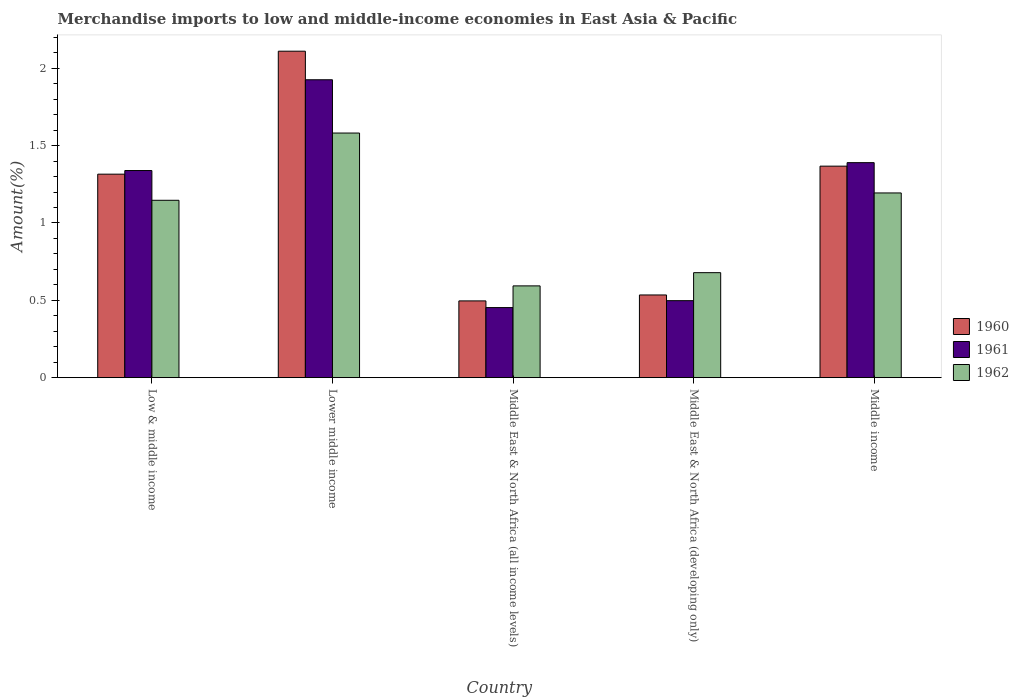How many different coloured bars are there?
Offer a terse response. 3. How many groups of bars are there?
Offer a terse response. 5. Are the number of bars per tick equal to the number of legend labels?
Provide a succinct answer. Yes. How many bars are there on the 4th tick from the left?
Give a very brief answer. 3. What is the percentage of amount earned from merchandise imports in 1961 in Middle East & North Africa (developing only)?
Give a very brief answer. 0.5. Across all countries, what is the maximum percentage of amount earned from merchandise imports in 1960?
Ensure brevity in your answer.  2.11. Across all countries, what is the minimum percentage of amount earned from merchandise imports in 1960?
Offer a very short reply. 0.5. In which country was the percentage of amount earned from merchandise imports in 1961 maximum?
Offer a very short reply. Lower middle income. In which country was the percentage of amount earned from merchandise imports in 1961 minimum?
Make the answer very short. Middle East & North Africa (all income levels). What is the total percentage of amount earned from merchandise imports in 1961 in the graph?
Your answer should be very brief. 5.61. What is the difference between the percentage of amount earned from merchandise imports in 1962 in Low & middle income and that in Middle East & North Africa (developing only)?
Provide a short and direct response. 0.47. What is the difference between the percentage of amount earned from merchandise imports in 1961 in Low & middle income and the percentage of amount earned from merchandise imports in 1962 in Middle East & North Africa (developing only)?
Your response must be concise. 0.66. What is the average percentage of amount earned from merchandise imports in 1960 per country?
Provide a succinct answer. 1.16. What is the difference between the percentage of amount earned from merchandise imports of/in 1961 and percentage of amount earned from merchandise imports of/in 1960 in Lower middle income?
Offer a terse response. -0.18. What is the ratio of the percentage of amount earned from merchandise imports in 1962 in Lower middle income to that in Middle East & North Africa (developing only)?
Your response must be concise. 2.33. Is the percentage of amount earned from merchandise imports in 1961 in Middle East & North Africa (developing only) less than that in Middle income?
Your response must be concise. Yes. Is the difference between the percentage of amount earned from merchandise imports in 1961 in Lower middle income and Middle East & North Africa (developing only) greater than the difference between the percentage of amount earned from merchandise imports in 1960 in Lower middle income and Middle East & North Africa (developing only)?
Provide a succinct answer. No. What is the difference between the highest and the second highest percentage of amount earned from merchandise imports in 1962?
Provide a short and direct response. 0.43. What is the difference between the highest and the lowest percentage of amount earned from merchandise imports in 1961?
Provide a short and direct response. 1.47. Is the sum of the percentage of amount earned from merchandise imports in 1961 in Middle East & North Africa (developing only) and Middle income greater than the maximum percentage of amount earned from merchandise imports in 1962 across all countries?
Ensure brevity in your answer.  Yes. What does the 3rd bar from the right in Middle East & North Africa (all income levels) represents?
Offer a very short reply. 1960. Is it the case that in every country, the sum of the percentage of amount earned from merchandise imports in 1960 and percentage of amount earned from merchandise imports in 1962 is greater than the percentage of amount earned from merchandise imports in 1961?
Provide a short and direct response. Yes. How many bars are there?
Offer a very short reply. 15. Are all the bars in the graph horizontal?
Offer a terse response. No. How many countries are there in the graph?
Provide a short and direct response. 5. Does the graph contain any zero values?
Make the answer very short. No. Does the graph contain grids?
Offer a terse response. No. Where does the legend appear in the graph?
Provide a succinct answer. Center right. How many legend labels are there?
Your answer should be compact. 3. What is the title of the graph?
Offer a very short reply. Merchandise imports to low and middle-income economies in East Asia & Pacific. Does "2005" appear as one of the legend labels in the graph?
Offer a very short reply. No. What is the label or title of the X-axis?
Provide a succinct answer. Country. What is the label or title of the Y-axis?
Provide a succinct answer. Amount(%). What is the Amount(%) of 1960 in Low & middle income?
Provide a short and direct response. 1.32. What is the Amount(%) of 1961 in Low & middle income?
Offer a terse response. 1.34. What is the Amount(%) of 1962 in Low & middle income?
Provide a succinct answer. 1.15. What is the Amount(%) in 1960 in Lower middle income?
Provide a succinct answer. 2.11. What is the Amount(%) of 1961 in Lower middle income?
Give a very brief answer. 1.93. What is the Amount(%) of 1962 in Lower middle income?
Offer a terse response. 1.58. What is the Amount(%) in 1960 in Middle East & North Africa (all income levels)?
Provide a short and direct response. 0.5. What is the Amount(%) in 1961 in Middle East & North Africa (all income levels)?
Your answer should be very brief. 0.45. What is the Amount(%) of 1962 in Middle East & North Africa (all income levels)?
Make the answer very short. 0.59. What is the Amount(%) in 1960 in Middle East & North Africa (developing only)?
Your answer should be compact. 0.53. What is the Amount(%) in 1961 in Middle East & North Africa (developing only)?
Make the answer very short. 0.5. What is the Amount(%) of 1962 in Middle East & North Africa (developing only)?
Make the answer very short. 0.68. What is the Amount(%) of 1960 in Middle income?
Your response must be concise. 1.37. What is the Amount(%) in 1961 in Middle income?
Offer a very short reply. 1.39. What is the Amount(%) in 1962 in Middle income?
Your response must be concise. 1.19. Across all countries, what is the maximum Amount(%) of 1960?
Your answer should be compact. 2.11. Across all countries, what is the maximum Amount(%) in 1961?
Ensure brevity in your answer.  1.93. Across all countries, what is the maximum Amount(%) in 1962?
Your answer should be compact. 1.58. Across all countries, what is the minimum Amount(%) in 1960?
Make the answer very short. 0.5. Across all countries, what is the minimum Amount(%) of 1961?
Your answer should be compact. 0.45. Across all countries, what is the minimum Amount(%) of 1962?
Offer a very short reply. 0.59. What is the total Amount(%) of 1960 in the graph?
Give a very brief answer. 5.82. What is the total Amount(%) of 1961 in the graph?
Ensure brevity in your answer.  5.61. What is the total Amount(%) of 1962 in the graph?
Provide a succinct answer. 5.2. What is the difference between the Amount(%) of 1960 in Low & middle income and that in Lower middle income?
Provide a succinct answer. -0.8. What is the difference between the Amount(%) in 1961 in Low & middle income and that in Lower middle income?
Offer a very short reply. -0.59. What is the difference between the Amount(%) of 1962 in Low & middle income and that in Lower middle income?
Provide a short and direct response. -0.43. What is the difference between the Amount(%) of 1960 in Low & middle income and that in Middle East & North Africa (all income levels)?
Offer a terse response. 0.82. What is the difference between the Amount(%) in 1961 in Low & middle income and that in Middle East & North Africa (all income levels)?
Your answer should be compact. 0.89. What is the difference between the Amount(%) of 1962 in Low & middle income and that in Middle East & North Africa (all income levels)?
Your answer should be very brief. 0.55. What is the difference between the Amount(%) of 1960 in Low & middle income and that in Middle East & North Africa (developing only)?
Give a very brief answer. 0.78. What is the difference between the Amount(%) of 1961 in Low & middle income and that in Middle East & North Africa (developing only)?
Your answer should be very brief. 0.84. What is the difference between the Amount(%) in 1962 in Low & middle income and that in Middle East & North Africa (developing only)?
Provide a succinct answer. 0.47. What is the difference between the Amount(%) of 1960 in Low & middle income and that in Middle income?
Offer a terse response. -0.05. What is the difference between the Amount(%) of 1961 in Low & middle income and that in Middle income?
Provide a succinct answer. -0.05. What is the difference between the Amount(%) of 1962 in Low & middle income and that in Middle income?
Provide a short and direct response. -0.05. What is the difference between the Amount(%) of 1960 in Lower middle income and that in Middle East & North Africa (all income levels)?
Provide a succinct answer. 1.61. What is the difference between the Amount(%) in 1961 in Lower middle income and that in Middle East & North Africa (all income levels)?
Offer a terse response. 1.47. What is the difference between the Amount(%) of 1960 in Lower middle income and that in Middle East & North Africa (developing only)?
Provide a short and direct response. 1.58. What is the difference between the Amount(%) in 1961 in Lower middle income and that in Middle East & North Africa (developing only)?
Provide a succinct answer. 1.43. What is the difference between the Amount(%) in 1962 in Lower middle income and that in Middle East & North Africa (developing only)?
Your answer should be very brief. 0.9. What is the difference between the Amount(%) in 1960 in Lower middle income and that in Middle income?
Your answer should be compact. 0.74. What is the difference between the Amount(%) of 1961 in Lower middle income and that in Middle income?
Your response must be concise. 0.54. What is the difference between the Amount(%) of 1962 in Lower middle income and that in Middle income?
Keep it short and to the point. 0.39. What is the difference between the Amount(%) in 1960 in Middle East & North Africa (all income levels) and that in Middle East & North Africa (developing only)?
Make the answer very short. -0.04. What is the difference between the Amount(%) of 1961 in Middle East & North Africa (all income levels) and that in Middle East & North Africa (developing only)?
Offer a terse response. -0.04. What is the difference between the Amount(%) of 1962 in Middle East & North Africa (all income levels) and that in Middle East & North Africa (developing only)?
Your answer should be compact. -0.09. What is the difference between the Amount(%) in 1960 in Middle East & North Africa (all income levels) and that in Middle income?
Keep it short and to the point. -0.87. What is the difference between the Amount(%) of 1961 in Middle East & North Africa (all income levels) and that in Middle income?
Make the answer very short. -0.94. What is the difference between the Amount(%) in 1962 in Middle East & North Africa (all income levels) and that in Middle income?
Keep it short and to the point. -0.6. What is the difference between the Amount(%) of 1960 in Middle East & North Africa (developing only) and that in Middle income?
Offer a very short reply. -0.83. What is the difference between the Amount(%) in 1961 in Middle East & North Africa (developing only) and that in Middle income?
Your answer should be very brief. -0.89. What is the difference between the Amount(%) of 1962 in Middle East & North Africa (developing only) and that in Middle income?
Your response must be concise. -0.52. What is the difference between the Amount(%) in 1960 in Low & middle income and the Amount(%) in 1961 in Lower middle income?
Provide a short and direct response. -0.61. What is the difference between the Amount(%) of 1960 in Low & middle income and the Amount(%) of 1962 in Lower middle income?
Keep it short and to the point. -0.27. What is the difference between the Amount(%) in 1961 in Low & middle income and the Amount(%) in 1962 in Lower middle income?
Provide a short and direct response. -0.24. What is the difference between the Amount(%) in 1960 in Low & middle income and the Amount(%) in 1961 in Middle East & North Africa (all income levels)?
Keep it short and to the point. 0.86. What is the difference between the Amount(%) of 1960 in Low & middle income and the Amount(%) of 1962 in Middle East & North Africa (all income levels)?
Give a very brief answer. 0.72. What is the difference between the Amount(%) of 1961 in Low & middle income and the Amount(%) of 1962 in Middle East & North Africa (all income levels)?
Your response must be concise. 0.75. What is the difference between the Amount(%) in 1960 in Low & middle income and the Amount(%) in 1961 in Middle East & North Africa (developing only)?
Offer a very short reply. 0.82. What is the difference between the Amount(%) of 1960 in Low & middle income and the Amount(%) of 1962 in Middle East & North Africa (developing only)?
Give a very brief answer. 0.64. What is the difference between the Amount(%) of 1961 in Low & middle income and the Amount(%) of 1962 in Middle East & North Africa (developing only)?
Give a very brief answer. 0.66. What is the difference between the Amount(%) of 1960 in Low & middle income and the Amount(%) of 1961 in Middle income?
Your answer should be compact. -0.07. What is the difference between the Amount(%) of 1960 in Low & middle income and the Amount(%) of 1962 in Middle income?
Offer a very short reply. 0.12. What is the difference between the Amount(%) of 1961 in Low & middle income and the Amount(%) of 1962 in Middle income?
Offer a terse response. 0.14. What is the difference between the Amount(%) in 1960 in Lower middle income and the Amount(%) in 1961 in Middle East & North Africa (all income levels)?
Ensure brevity in your answer.  1.66. What is the difference between the Amount(%) of 1960 in Lower middle income and the Amount(%) of 1962 in Middle East & North Africa (all income levels)?
Give a very brief answer. 1.52. What is the difference between the Amount(%) of 1961 in Lower middle income and the Amount(%) of 1962 in Middle East & North Africa (all income levels)?
Your response must be concise. 1.33. What is the difference between the Amount(%) of 1960 in Lower middle income and the Amount(%) of 1961 in Middle East & North Africa (developing only)?
Your answer should be very brief. 1.61. What is the difference between the Amount(%) in 1960 in Lower middle income and the Amount(%) in 1962 in Middle East & North Africa (developing only)?
Your answer should be compact. 1.43. What is the difference between the Amount(%) in 1961 in Lower middle income and the Amount(%) in 1962 in Middle East & North Africa (developing only)?
Make the answer very short. 1.25. What is the difference between the Amount(%) of 1960 in Lower middle income and the Amount(%) of 1961 in Middle income?
Offer a very short reply. 0.72. What is the difference between the Amount(%) of 1960 in Lower middle income and the Amount(%) of 1962 in Middle income?
Make the answer very short. 0.92. What is the difference between the Amount(%) of 1961 in Lower middle income and the Amount(%) of 1962 in Middle income?
Make the answer very short. 0.73. What is the difference between the Amount(%) of 1960 in Middle East & North Africa (all income levels) and the Amount(%) of 1961 in Middle East & North Africa (developing only)?
Give a very brief answer. -0. What is the difference between the Amount(%) in 1960 in Middle East & North Africa (all income levels) and the Amount(%) in 1962 in Middle East & North Africa (developing only)?
Offer a terse response. -0.18. What is the difference between the Amount(%) of 1961 in Middle East & North Africa (all income levels) and the Amount(%) of 1962 in Middle East & North Africa (developing only)?
Your response must be concise. -0.23. What is the difference between the Amount(%) in 1960 in Middle East & North Africa (all income levels) and the Amount(%) in 1961 in Middle income?
Provide a succinct answer. -0.89. What is the difference between the Amount(%) in 1960 in Middle East & North Africa (all income levels) and the Amount(%) in 1962 in Middle income?
Ensure brevity in your answer.  -0.7. What is the difference between the Amount(%) of 1961 in Middle East & North Africa (all income levels) and the Amount(%) of 1962 in Middle income?
Keep it short and to the point. -0.74. What is the difference between the Amount(%) of 1960 in Middle East & North Africa (developing only) and the Amount(%) of 1961 in Middle income?
Keep it short and to the point. -0.86. What is the difference between the Amount(%) of 1960 in Middle East & North Africa (developing only) and the Amount(%) of 1962 in Middle income?
Keep it short and to the point. -0.66. What is the difference between the Amount(%) of 1961 in Middle East & North Africa (developing only) and the Amount(%) of 1962 in Middle income?
Provide a succinct answer. -0.7. What is the average Amount(%) of 1960 per country?
Give a very brief answer. 1.17. What is the average Amount(%) of 1961 per country?
Give a very brief answer. 1.12. What is the average Amount(%) of 1962 per country?
Your answer should be very brief. 1.04. What is the difference between the Amount(%) in 1960 and Amount(%) in 1961 in Low & middle income?
Keep it short and to the point. -0.02. What is the difference between the Amount(%) of 1960 and Amount(%) of 1962 in Low & middle income?
Offer a terse response. 0.17. What is the difference between the Amount(%) of 1961 and Amount(%) of 1962 in Low & middle income?
Your answer should be compact. 0.19. What is the difference between the Amount(%) of 1960 and Amount(%) of 1961 in Lower middle income?
Keep it short and to the point. 0.18. What is the difference between the Amount(%) in 1960 and Amount(%) in 1962 in Lower middle income?
Provide a succinct answer. 0.53. What is the difference between the Amount(%) of 1961 and Amount(%) of 1962 in Lower middle income?
Keep it short and to the point. 0.34. What is the difference between the Amount(%) of 1960 and Amount(%) of 1961 in Middle East & North Africa (all income levels)?
Keep it short and to the point. 0.04. What is the difference between the Amount(%) of 1960 and Amount(%) of 1962 in Middle East & North Africa (all income levels)?
Give a very brief answer. -0.1. What is the difference between the Amount(%) of 1961 and Amount(%) of 1962 in Middle East & North Africa (all income levels)?
Give a very brief answer. -0.14. What is the difference between the Amount(%) of 1960 and Amount(%) of 1961 in Middle East & North Africa (developing only)?
Your answer should be very brief. 0.04. What is the difference between the Amount(%) of 1960 and Amount(%) of 1962 in Middle East & North Africa (developing only)?
Provide a succinct answer. -0.14. What is the difference between the Amount(%) in 1961 and Amount(%) in 1962 in Middle East & North Africa (developing only)?
Make the answer very short. -0.18. What is the difference between the Amount(%) of 1960 and Amount(%) of 1961 in Middle income?
Ensure brevity in your answer.  -0.02. What is the difference between the Amount(%) of 1960 and Amount(%) of 1962 in Middle income?
Your answer should be very brief. 0.17. What is the difference between the Amount(%) of 1961 and Amount(%) of 1962 in Middle income?
Provide a short and direct response. 0.2. What is the ratio of the Amount(%) in 1960 in Low & middle income to that in Lower middle income?
Give a very brief answer. 0.62. What is the ratio of the Amount(%) of 1961 in Low & middle income to that in Lower middle income?
Give a very brief answer. 0.7. What is the ratio of the Amount(%) of 1962 in Low & middle income to that in Lower middle income?
Your answer should be compact. 0.73. What is the ratio of the Amount(%) of 1960 in Low & middle income to that in Middle East & North Africa (all income levels)?
Offer a very short reply. 2.65. What is the ratio of the Amount(%) of 1961 in Low & middle income to that in Middle East & North Africa (all income levels)?
Provide a short and direct response. 2.96. What is the ratio of the Amount(%) in 1962 in Low & middle income to that in Middle East & North Africa (all income levels)?
Offer a terse response. 1.93. What is the ratio of the Amount(%) of 1960 in Low & middle income to that in Middle East & North Africa (developing only)?
Provide a succinct answer. 2.46. What is the ratio of the Amount(%) of 1961 in Low & middle income to that in Middle East & North Africa (developing only)?
Provide a short and direct response. 2.69. What is the ratio of the Amount(%) in 1962 in Low & middle income to that in Middle East & North Africa (developing only)?
Keep it short and to the point. 1.69. What is the ratio of the Amount(%) in 1960 in Low & middle income to that in Middle income?
Offer a terse response. 0.96. What is the ratio of the Amount(%) in 1961 in Low & middle income to that in Middle income?
Your answer should be compact. 0.96. What is the ratio of the Amount(%) in 1962 in Low & middle income to that in Middle income?
Offer a terse response. 0.96. What is the ratio of the Amount(%) of 1960 in Lower middle income to that in Middle East & North Africa (all income levels)?
Keep it short and to the point. 4.25. What is the ratio of the Amount(%) in 1961 in Lower middle income to that in Middle East & North Africa (all income levels)?
Give a very brief answer. 4.25. What is the ratio of the Amount(%) of 1962 in Lower middle income to that in Middle East & North Africa (all income levels)?
Your response must be concise. 2.67. What is the ratio of the Amount(%) of 1960 in Lower middle income to that in Middle East & North Africa (developing only)?
Your answer should be very brief. 3.95. What is the ratio of the Amount(%) of 1961 in Lower middle income to that in Middle East & North Africa (developing only)?
Your response must be concise. 3.87. What is the ratio of the Amount(%) in 1962 in Lower middle income to that in Middle East & North Africa (developing only)?
Offer a very short reply. 2.33. What is the ratio of the Amount(%) in 1960 in Lower middle income to that in Middle income?
Make the answer very short. 1.54. What is the ratio of the Amount(%) in 1961 in Lower middle income to that in Middle income?
Ensure brevity in your answer.  1.39. What is the ratio of the Amount(%) of 1962 in Lower middle income to that in Middle income?
Provide a succinct answer. 1.32. What is the ratio of the Amount(%) of 1960 in Middle East & North Africa (all income levels) to that in Middle East & North Africa (developing only)?
Your response must be concise. 0.93. What is the ratio of the Amount(%) of 1961 in Middle East & North Africa (all income levels) to that in Middle East & North Africa (developing only)?
Your answer should be very brief. 0.91. What is the ratio of the Amount(%) in 1962 in Middle East & North Africa (all income levels) to that in Middle East & North Africa (developing only)?
Your answer should be very brief. 0.87. What is the ratio of the Amount(%) in 1960 in Middle East & North Africa (all income levels) to that in Middle income?
Your answer should be compact. 0.36. What is the ratio of the Amount(%) in 1961 in Middle East & North Africa (all income levels) to that in Middle income?
Provide a short and direct response. 0.33. What is the ratio of the Amount(%) of 1962 in Middle East & North Africa (all income levels) to that in Middle income?
Provide a succinct answer. 0.5. What is the ratio of the Amount(%) of 1960 in Middle East & North Africa (developing only) to that in Middle income?
Offer a terse response. 0.39. What is the ratio of the Amount(%) of 1961 in Middle East & North Africa (developing only) to that in Middle income?
Your answer should be compact. 0.36. What is the ratio of the Amount(%) in 1962 in Middle East & North Africa (developing only) to that in Middle income?
Provide a short and direct response. 0.57. What is the difference between the highest and the second highest Amount(%) in 1960?
Your answer should be very brief. 0.74. What is the difference between the highest and the second highest Amount(%) of 1961?
Offer a very short reply. 0.54. What is the difference between the highest and the second highest Amount(%) of 1962?
Give a very brief answer. 0.39. What is the difference between the highest and the lowest Amount(%) of 1960?
Ensure brevity in your answer.  1.61. What is the difference between the highest and the lowest Amount(%) in 1961?
Ensure brevity in your answer.  1.47. 